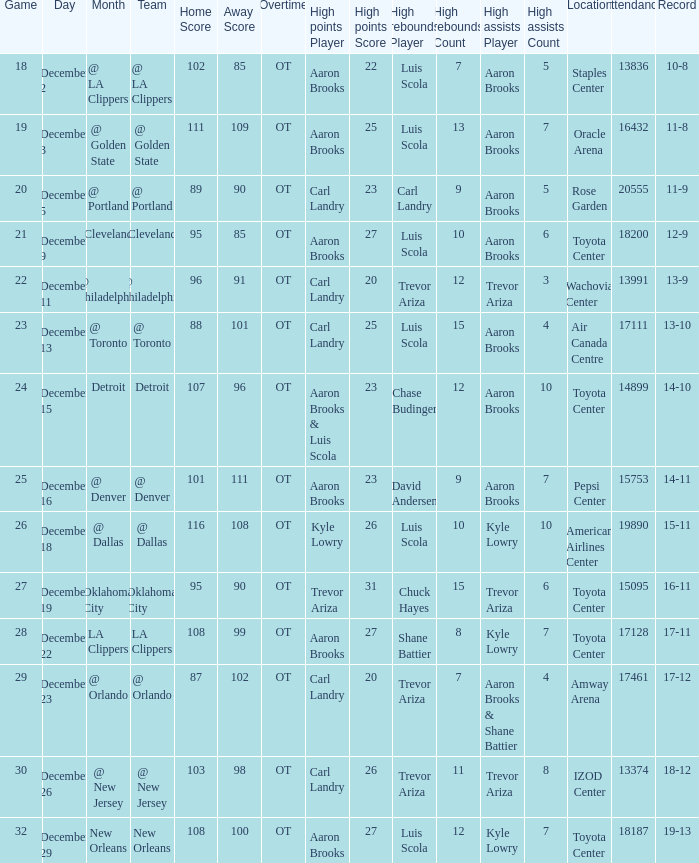Who did the high rebounds in the game where Carl Landry (23) did the most high points? Carl Landry (9). 